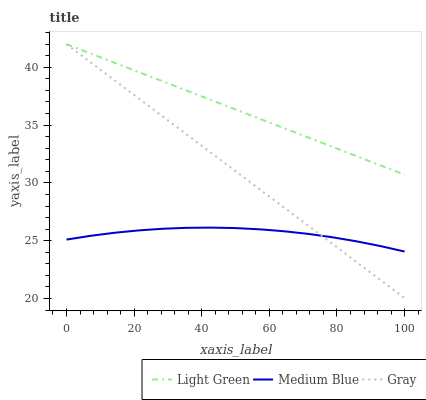Does Medium Blue have the minimum area under the curve?
Answer yes or no. Yes. Does Light Green have the maximum area under the curve?
Answer yes or no. Yes. Does Light Green have the minimum area under the curve?
Answer yes or no. No. Does Medium Blue have the maximum area under the curve?
Answer yes or no. No. Is Gray the smoothest?
Answer yes or no. Yes. Is Medium Blue the roughest?
Answer yes or no. Yes. Is Light Green the smoothest?
Answer yes or no. No. Is Light Green the roughest?
Answer yes or no. No. Does Medium Blue have the lowest value?
Answer yes or no. No. Does Medium Blue have the highest value?
Answer yes or no. No. Is Medium Blue less than Light Green?
Answer yes or no. Yes. Is Light Green greater than Medium Blue?
Answer yes or no. Yes. Does Medium Blue intersect Light Green?
Answer yes or no. No. 